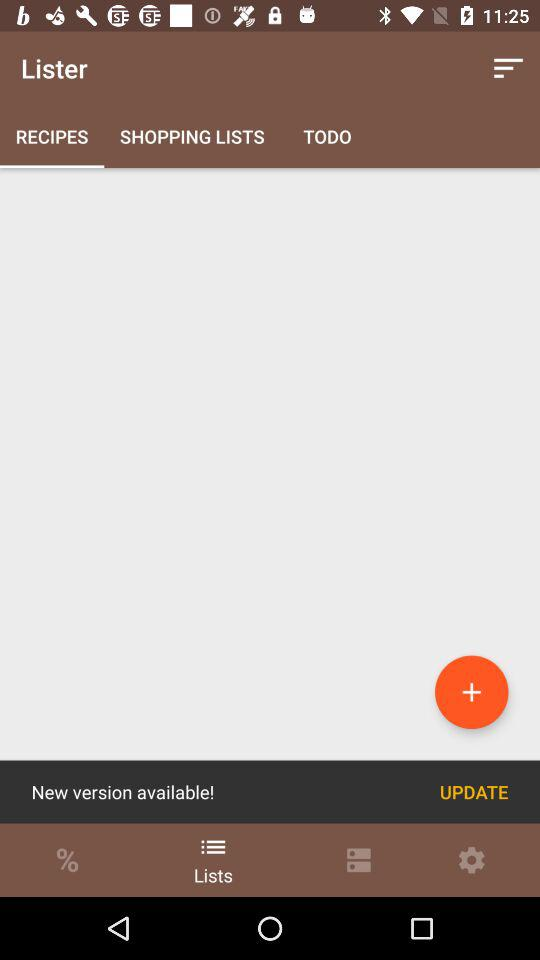Which tab is selected? The selected tabs are "RECIPES" and "Lists". 